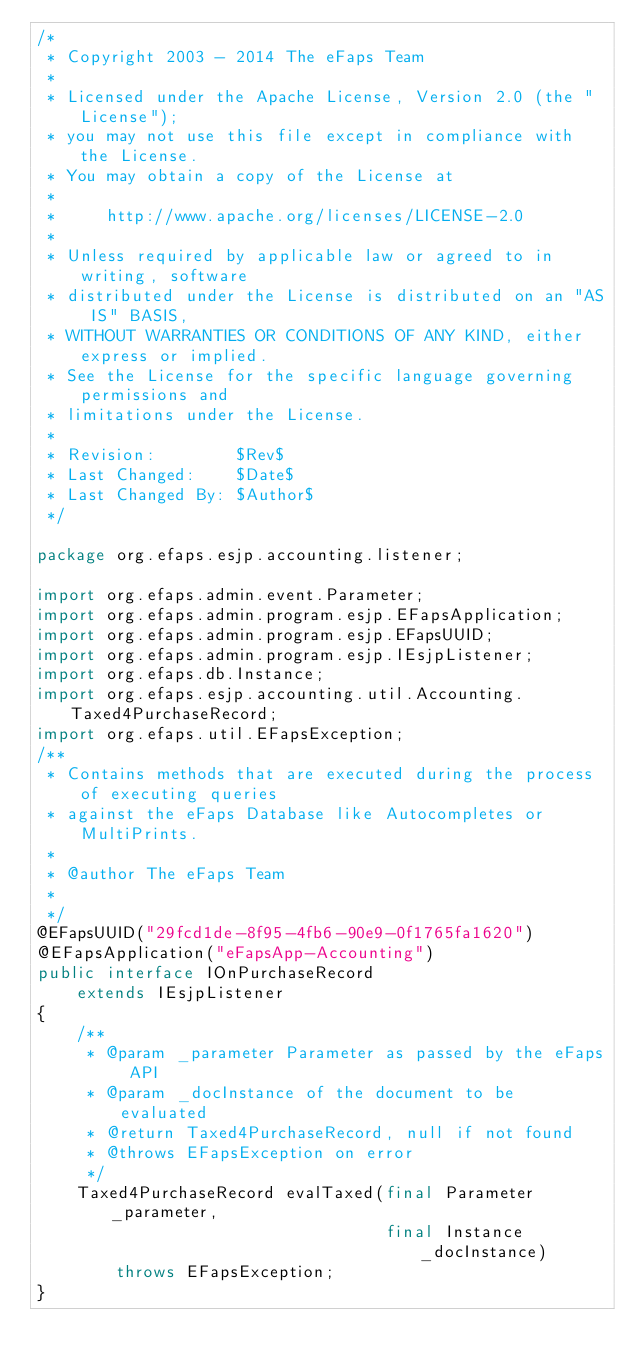<code> <loc_0><loc_0><loc_500><loc_500><_Java_>/*
 * Copyright 2003 - 2014 The eFaps Team
 *
 * Licensed under the Apache License, Version 2.0 (the "License");
 * you may not use this file except in compliance with the License.
 * You may obtain a copy of the License at
 *
 *     http://www.apache.org/licenses/LICENSE-2.0
 *
 * Unless required by applicable law or agreed to in writing, software
 * distributed under the License is distributed on an "AS IS" BASIS,
 * WITHOUT WARRANTIES OR CONDITIONS OF ANY KIND, either express or implied.
 * See the License for the specific language governing permissions and
 * limitations under the License.
 *
 * Revision:        $Rev$
 * Last Changed:    $Date$
 * Last Changed By: $Author$
 */

package org.efaps.esjp.accounting.listener;

import org.efaps.admin.event.Parameter;
import org.efaps.admin.program.esjp.EFapsApplication;
import org.efaps.admin.program.esjp.EFapsUUID;
import org.efaps.admin.program.esjp.IEsjpListener;
import org.efaps.db.Instance;
import org.efaps.esjp.accounting.util.Accounting.Taxed4PurchaseRecord;
import org.efaps.util.EFapsException;
/**
 * Contains methods that are executed during the process of executing queries
 * against the eFaps Database like Autocompletes or MultiPrints.
 *
 * @author The eFaps Team
 * 
 */
@EFapsUUID("29fcd1de-8f95-4fb6-90e9-0f1765fa1620")
@EFapsApplication("eFapsApp-Accounting")
public interface IOnPurchaseRecord
    extends IEsjpListener
{
    /**
     * @param _parameter Parameter as passed by the eFaps API
     * @param _docInstance of the document to be evaluated
     * @return Taxed4PurchaseRecord, null if not found
     * @throws EFapsException on error
     */
    Taxed4PurchaseRecord evalTaxed(final Parameter _parameter,
                                   final Instance _docInstance)
        throws EFapsException;
}
</code> 